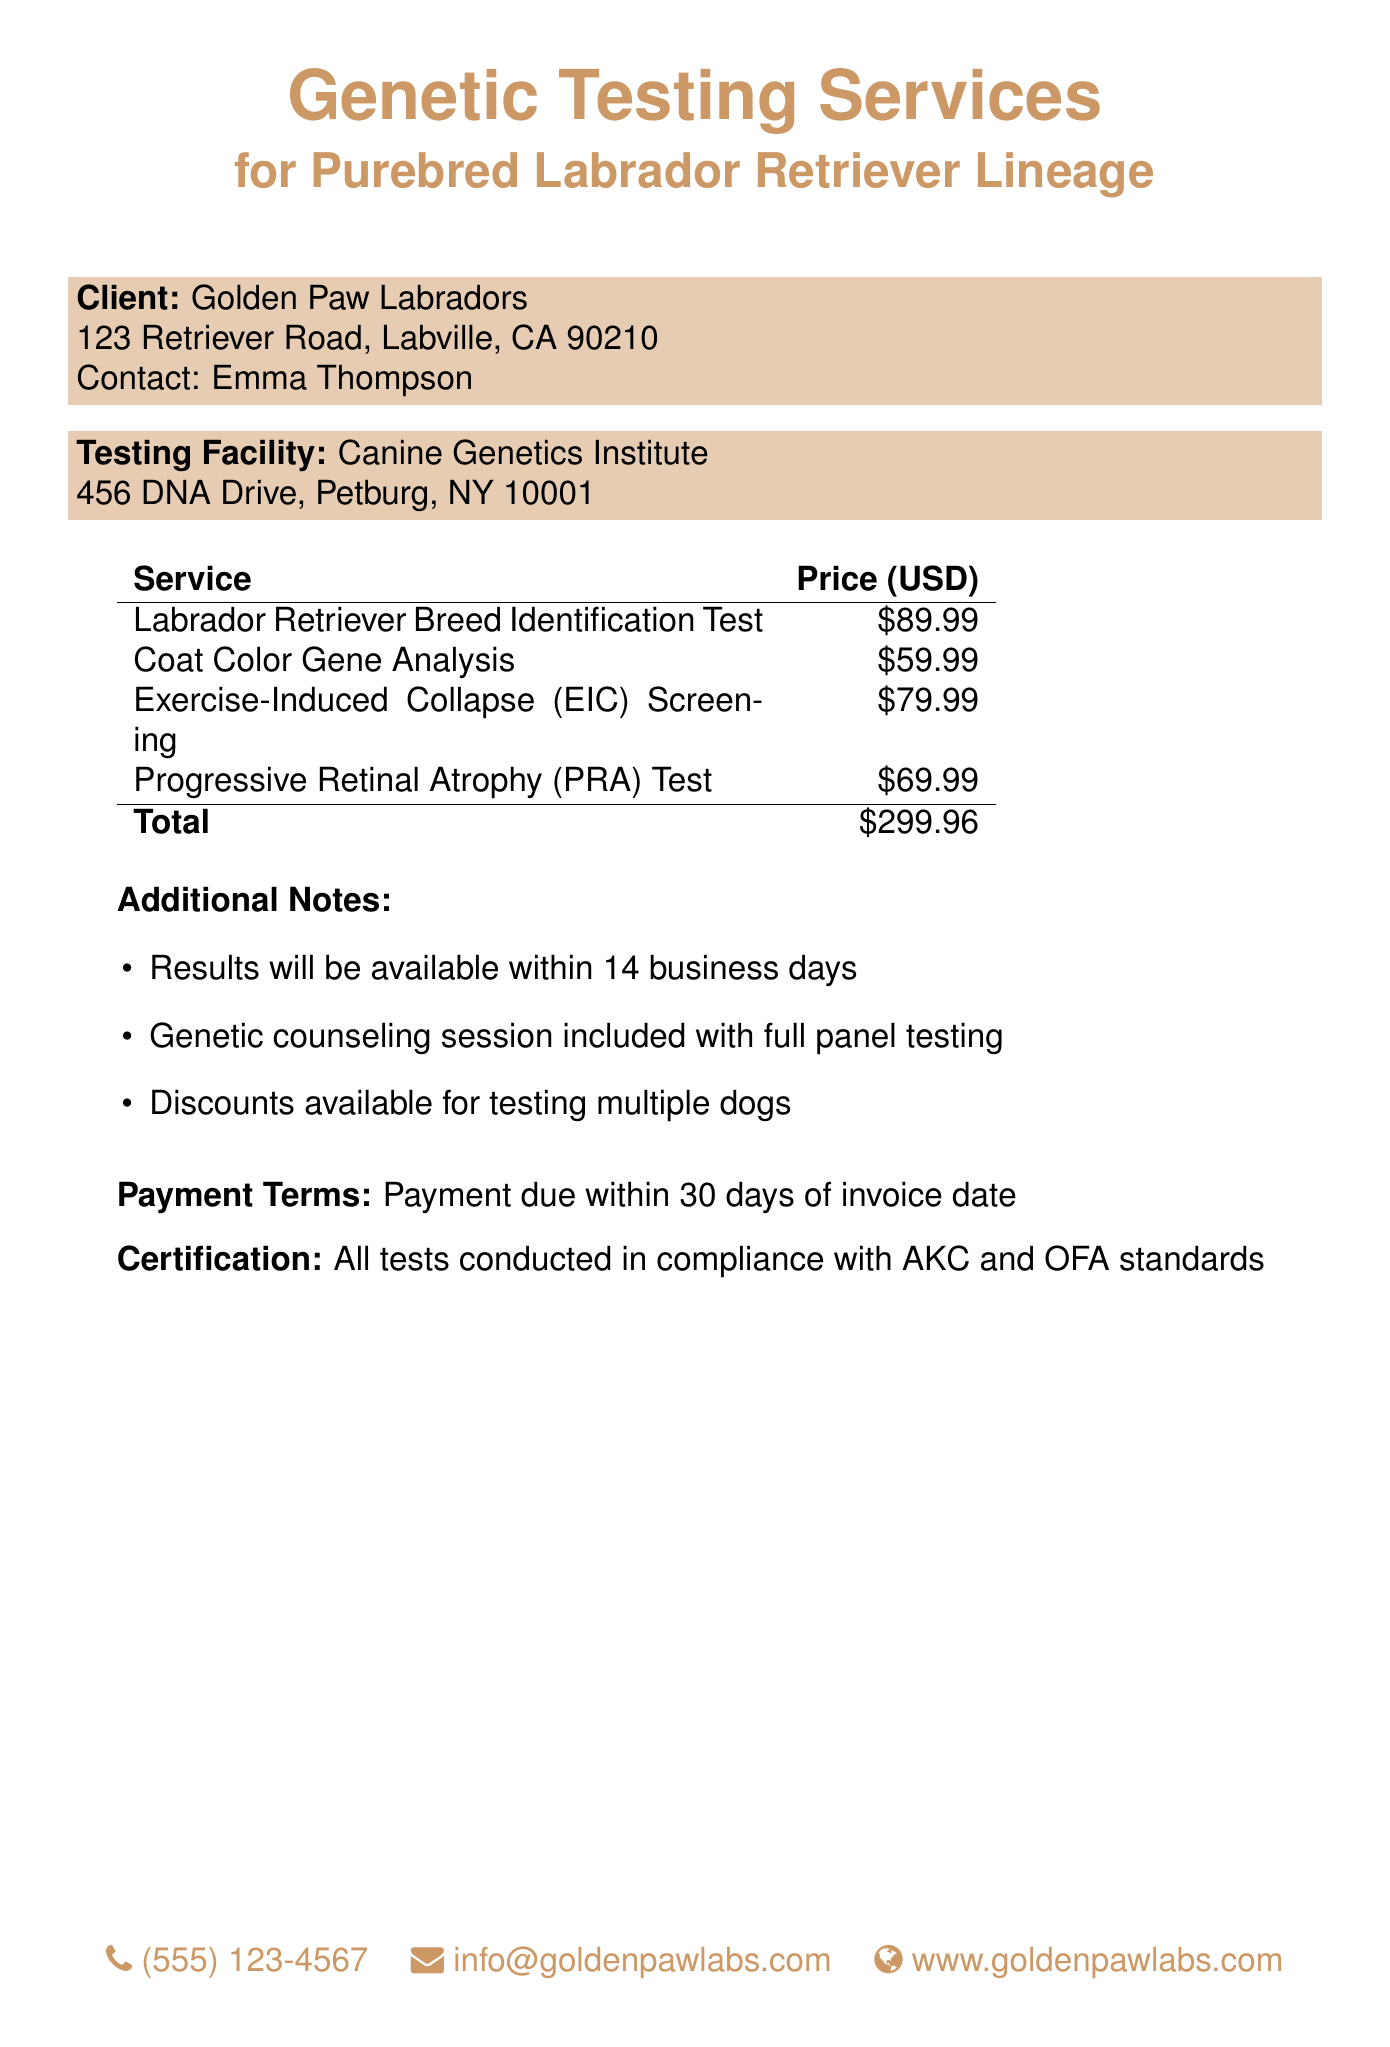What is the name of the client? The client is mentioned in the document as Golden Paw Labradors.
Answer: Golden Paw Labradors How much does the Exercise-Induced Collapse (EIC) Screening cost? The cost for the EIC Screening is specifically listed in the table of services.
Answer: $79.99 What is the total price for all services listed? The document provides a total price that sums all the individual services.
Answer: $299.96 How long will it take to receive the results? The document states that the results will be available within a specific timeframe.
Answer: 14 business days What does the certification state about testing compliance? The document mentions specific standards that all tests follow.
Answer: AKC and OFA standards What additional service is included with full panel testing? The document lists an additional service that comes with full panel testing.
Answer: Genetic counseling session What is the payment term specified in the document? The document outlines the time frame for payment due after receiving the invoice.
Answer: 30 days How can the client contact Golden Paw Labradors? The document provides contact details, including phone, email, and website.
Answer: (555) 123-4567 